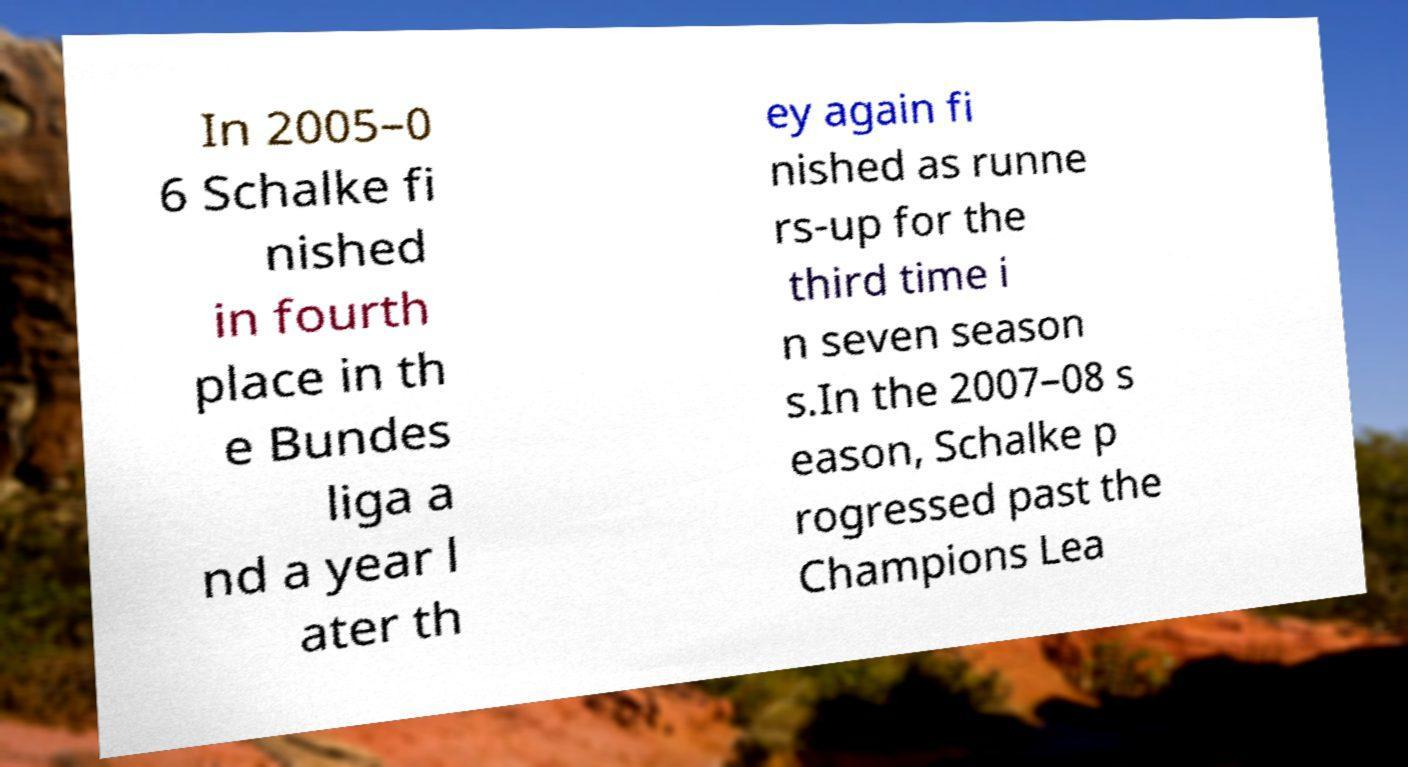For documentation purposes, I need the text within this image transcribed. Could you provide that? In 2005–0 6 Schalke fi nished in fourth place in th e Bundes liga a nd a year l ater th ey again fi nished as runne rs-up for the third time i n seven season s.In the 2007–08 s eason, Schalke p rogressed past the Champions Lea 